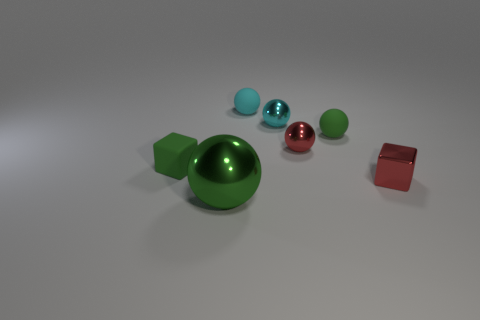Subtract 1 balls. How many balls are left? 4 Subtract all red spheres. How many spheres are left? 4 Subtract all green matte balls. How many balls are left? 4 Subtract all purple balls. Subtract all gray cylinders. How many balls are left? 5 Add 1 big brown metal things. How many objects exist? 8 Subtract all cubes. How many objects are left? 5 Subtract 0 red cylinders. How many objects are left? 7 Subtract all large green metal spheres. Subtract all large gray metallic objects. How many objects are left? 6 Add 5 red metallic spheres. How many red metallic spheres are left? 6 Add 2 red metallic blocks. How many red metallic blocks exist? 3 